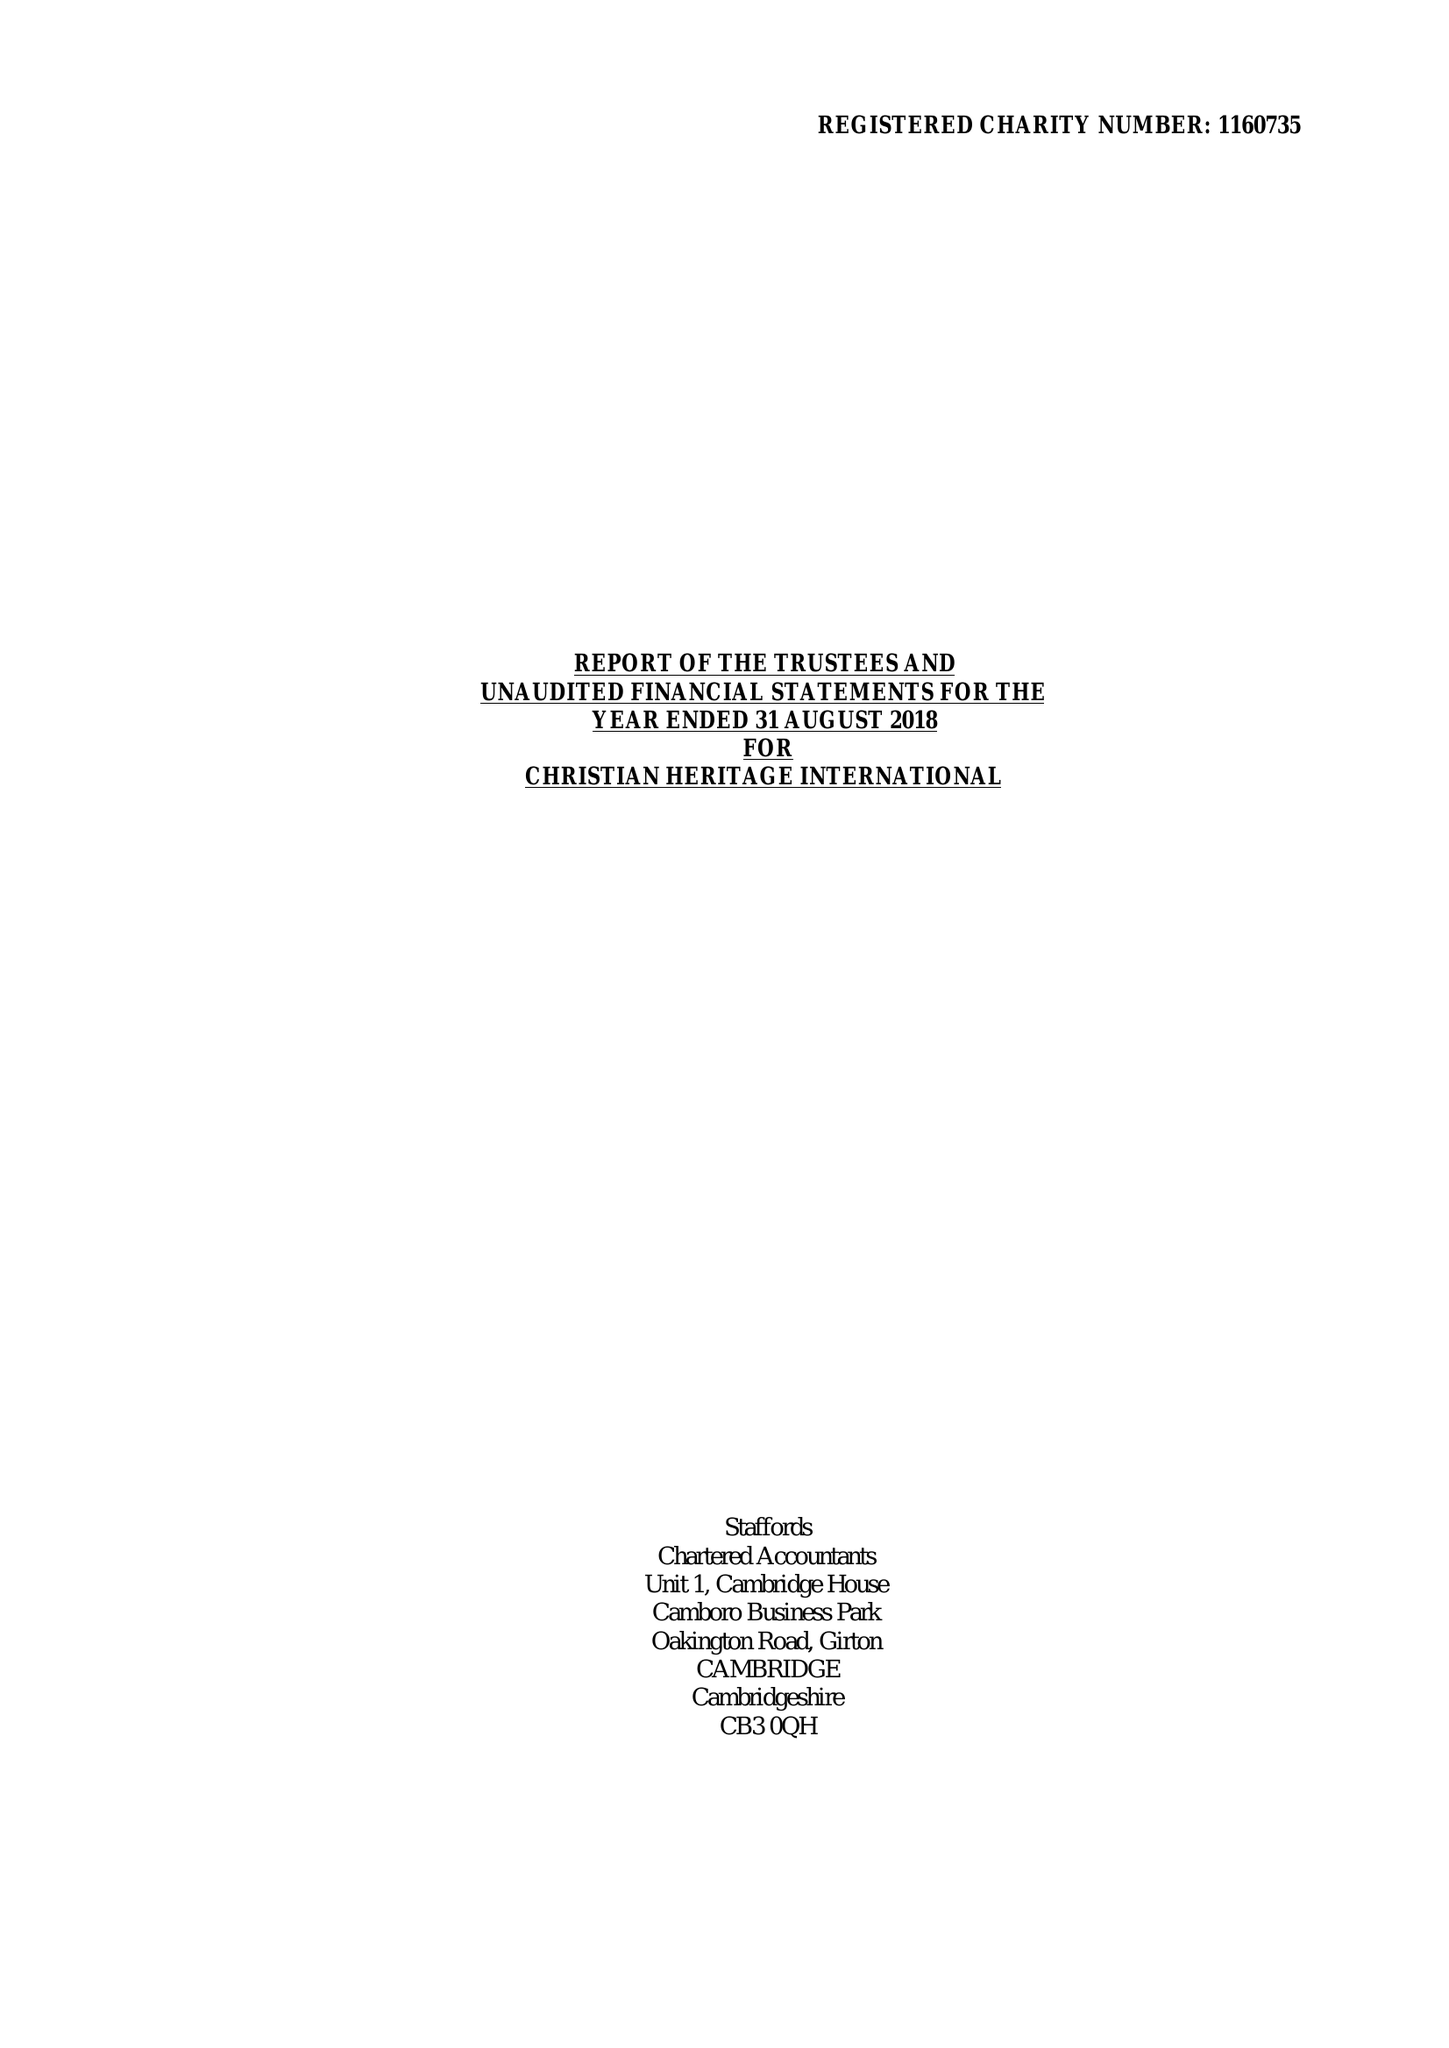What is the value for the address__post_town?
Answer the question using a single word or phrase. NORTHWOOD 